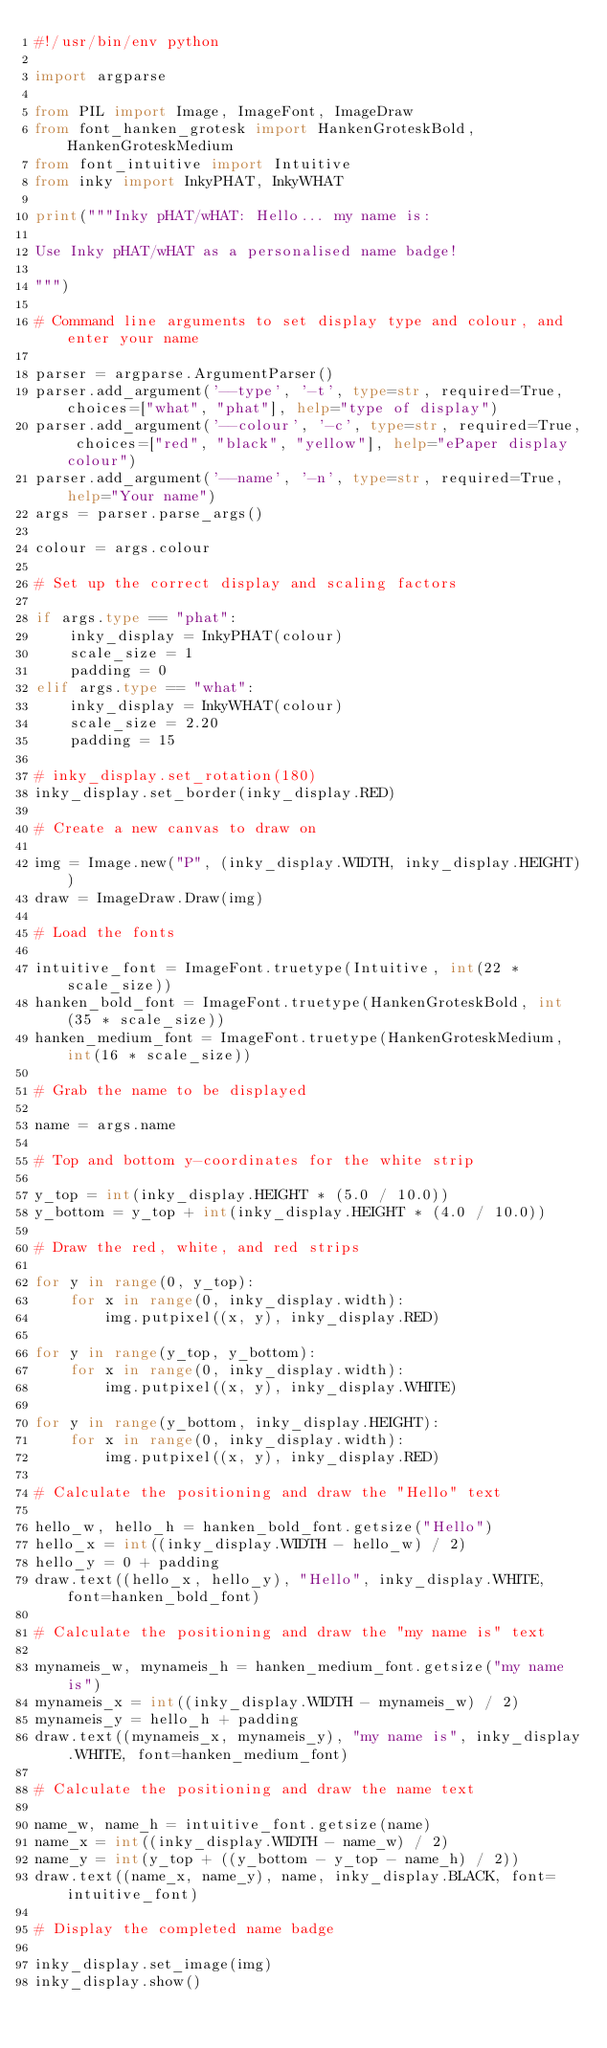Convert code to text. <code><loc_0><loc_0><loc_500><loc_500><_Python_>#!/usr/bin/env python

import argparse

from PIL import Image, ImageFont, ImageDraw
from font_hanken_grotesk import HankenGroteskBold, HankenGroteskMedium
from font_intuitive import Intuitive
from inky import InkyPHAT, InkyWHAT

print("""Inky pHAT/wHAT: Hello... my name is:

Use Inky pHAT/wHAT as a personalised name badge!

""")

# Command line arguments to set display type and colour, and enter your name

parser = argparse.ArgumentParser()
parser.add_argument('--type', '-t', type=str, required=True, choices=["what", "phat"], help="type of display")
parser.add_argument('--colour', '-c', type=str, required=True, choices=["red", "black", "yellow"], help="ePaper display colour")
parser.add_argument('--name', '-n', type=str, required=True, help="Your name")
args = parser.parse_args()

colour = args.colour

# Set up the correct display and scaling factors

if args.type == "phat":
    inky_display = InkyPHAT(colour)
    scale_size = 1
    padding = 0
elif args.type == "what":
    inky_display = InkyWHAT(colour)
    scale_size = 2.20
    padding = 15

# inky_display.set_rotation(180)
inky_display.set_border(inky_display.RED)

# Create a new canvas to draw on

img = Image.new("P", (inky_display.WIDTH, inky_display.HEIGHT))
draw = ImageDraw.Draw(img)

# Load the fonts

intuitive_font = ImageFont.truetype(Intuitive, int(22 * scale_size))
hanken_bold_font = ImageFont.truetype(HankenGroteskBold, int(35 * scale_size))
hanken_medium_font = ImageFont.truetype(HankenGroteskMedium, int(16 * scale_size))

# Grab the name to be displayed

name = args.name

# Top and bottom y-coordinates for the white strip

y_top = int(inky_display.HEIGHT * (5.0 / 10.0))
y_bottom = y_top + int(inky_display.HEIGHT * (4.0 / 10.0))

# Draw the red, white, and red strips

for y in range(0, y_top):
    for x in range(0, inky_display.width):
        img.putpixel((x, y), inky_display.RED)

for y in range(y_top, y_bottom):
    for x in range(0, inky_display.width):
        img.putpixel((x, y), inky_display.WHITE)

for y in range(y_bottom, inky_display.HEIGHT):
    for x in range(0, inky_display.width):
        img.putpixel((x, y), inky_display.RED)

# Calculate the positioning and draw the "Hello" text

hello_w, hello_h = hanken_bold_font.getsize("Hello")
hello_x = int((inky_display.WIDTH - hello_w) / 2)
hello_y = 0 + padding
draw.text((hello_x, hello_y), "Hello", inky_display.WHITE, font=hanken_bold_font)

# Calculate the positioning and draw the "my name is" text

mynameis_w, mynameis_h = hanken_medium_font.getsize("my name is")
mynameis_x = int((inky_display.WIDTH - mynameis_w) / 2)
mynameis_y = hello_h + padding
draw.text((mynameis_x, mynameis_y), "my name is", inky_display.WHITE, font=hanken_medium_font)

# Calculate the positioning and draw the name text

name_w, name_h = intuitive_font.getsize(name)
name_x = int((inky_display.WIDTH - name_w) / 2)
name_y = int(y_top + ((y_bottom - y_top - name_h) / 2))
draw.text((name_x, name_y), name, inky_display.BLACK, font=intuitive_font)

# Display the completed name badge

inky_display.set_image(img)
inky_display.show()
</code> 